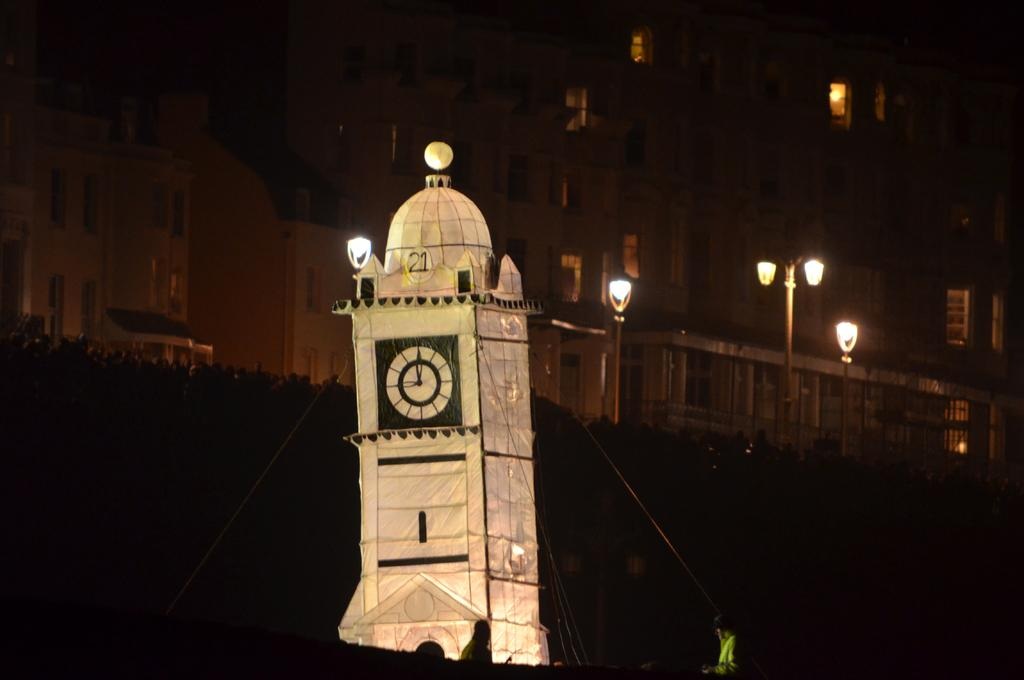What type of structures can be seen in the image? There are multiple buildings in the image. Are there any specific features related to lighting in the image? Yes, there are light poles in the image. What type of architectural feature is present in the image? There is a clock tower in the image. How would you describe the overall lighting condition in the image? The image appears to be a bit dark. What type of notebook can be seen hanging from the clock tower in the image? There is no notebook present in the image, and it is not hanging from the clock tower. 